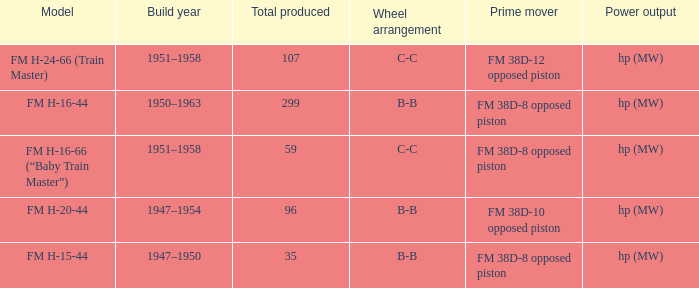Which is the smallest Total produced with a model of FM H-15-44? 35.0. 